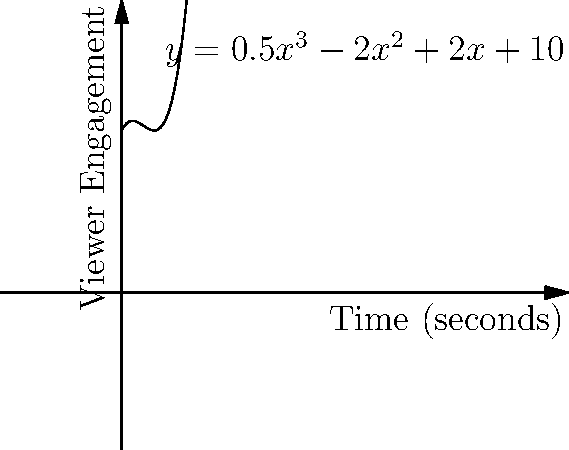A car commercial's viewer engagement over time is modeled by the function $y = 0.5x^3 - 2x^2 + 2x + 10$, where $y$ represents the engagement level and $x$ represents time in seconds. At what point during the commercial is the rate of change in viewer engagement the highest? To find the point of highest rate of change in viewer engagement, we need to follow these steps:

1) The rate of change is represented by the first derivative of the function. Let's call this $y'$.

2) Find $y'$ by differentiating $y$ with respect to $x$:
   $y' = 1.5x^2 - 4x + 2$

3) The highest rate of change will occur where the second derivative ($y''$) equals zero.

4) Find $y''$ by differentiating $y'$:
   $y'' = 3x - 4$

5) Set $y'' = 0$ and solve for $x$:
   $3x - 4 = 0$
   $3x = 4$
   $x = \frac{4}{3}$

6) To confirm this is a maximum, we can check that $y'''$ is negative:
   $y''' = 3$, which is positive, confirming $x = \frac{4}{3}$ gives a minimum for $y'$.

7) Therefore, the rate of change is highest at $x = \frac{4}{3}$ seconds.
Answer: $\frac{4}{3}$ seconds 